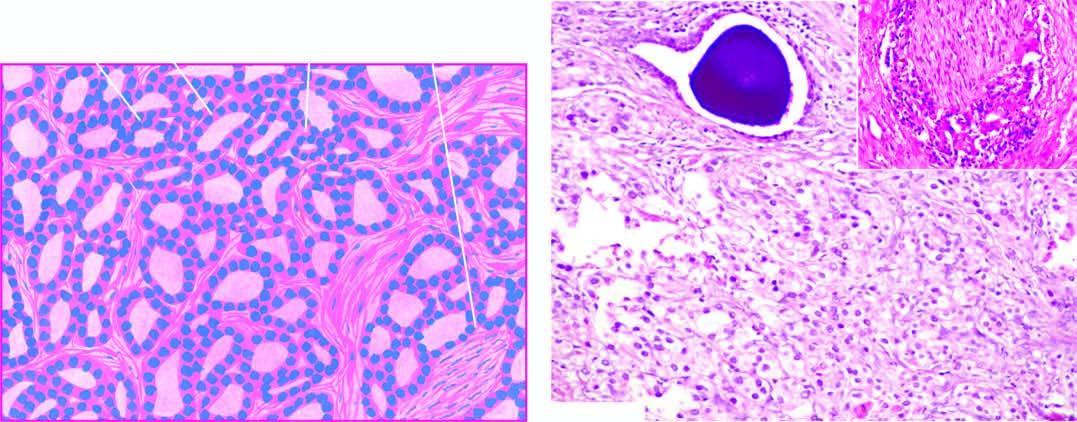what does the field show?
Answer the question using a single word or phrase. Microacini of small malignant cells infiltrating the prostatic stroma 